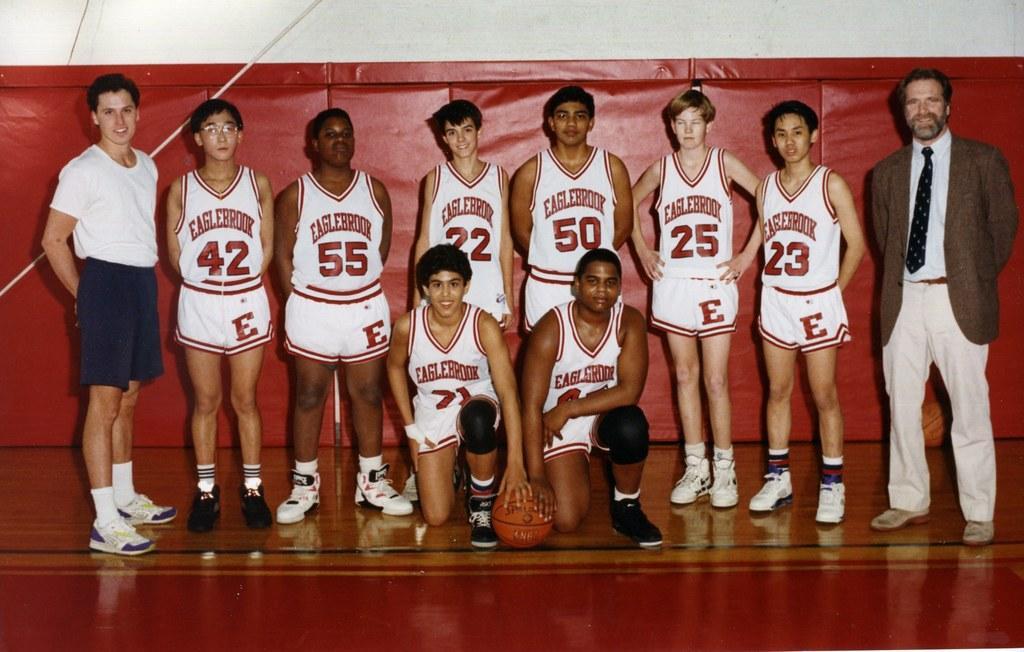Describe this image in one or two sentences. This picture describes about group of people, in front of them we can see a ball, behind them we can find a rope. 